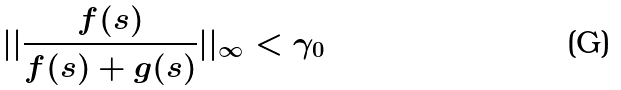Convert formula to latex. <formula><loc_0><loc_0><loc_500><loc_500>| | \frac { f ( s ) } { f ( s ) + g ( s ) } | | _ { \infty } < \gamma _ { 0 }</formula> 